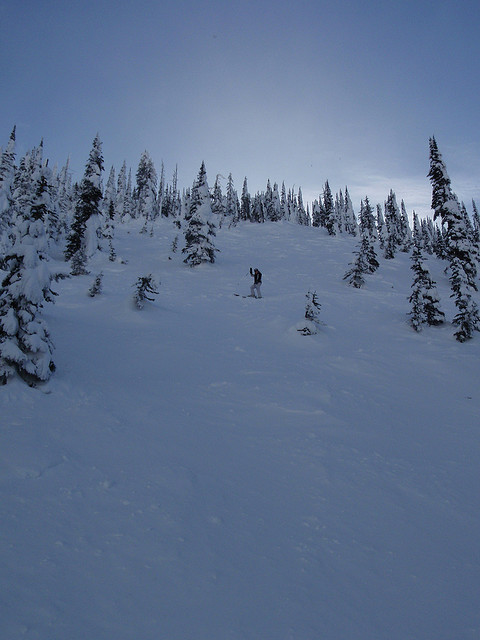What is the condition of the slope in the image? The slope in the image is covered by a blanket of powdery snow that appears well-suited for snowboarding and skiing. The area is flanked by densely populated evergreen trees, adding both a visual appeal and a natural barrier that enhances the safety of the run. 